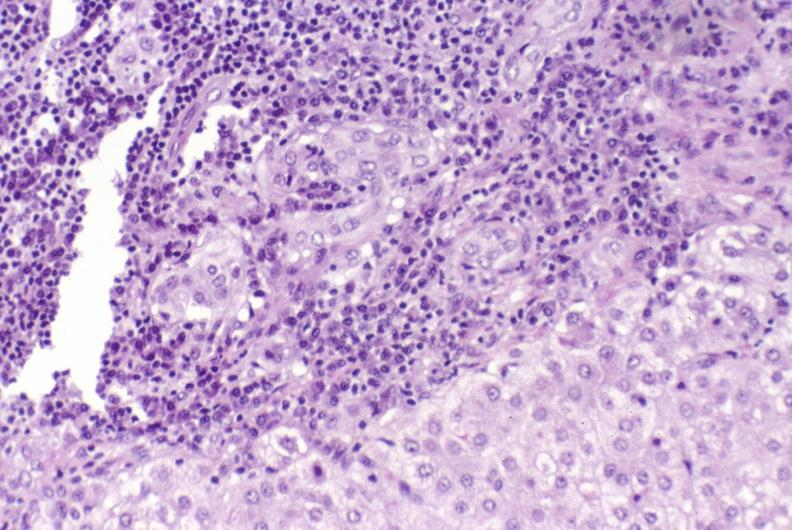s hepatobiliary present?
Answer the question using a single word or phrase. Yes 